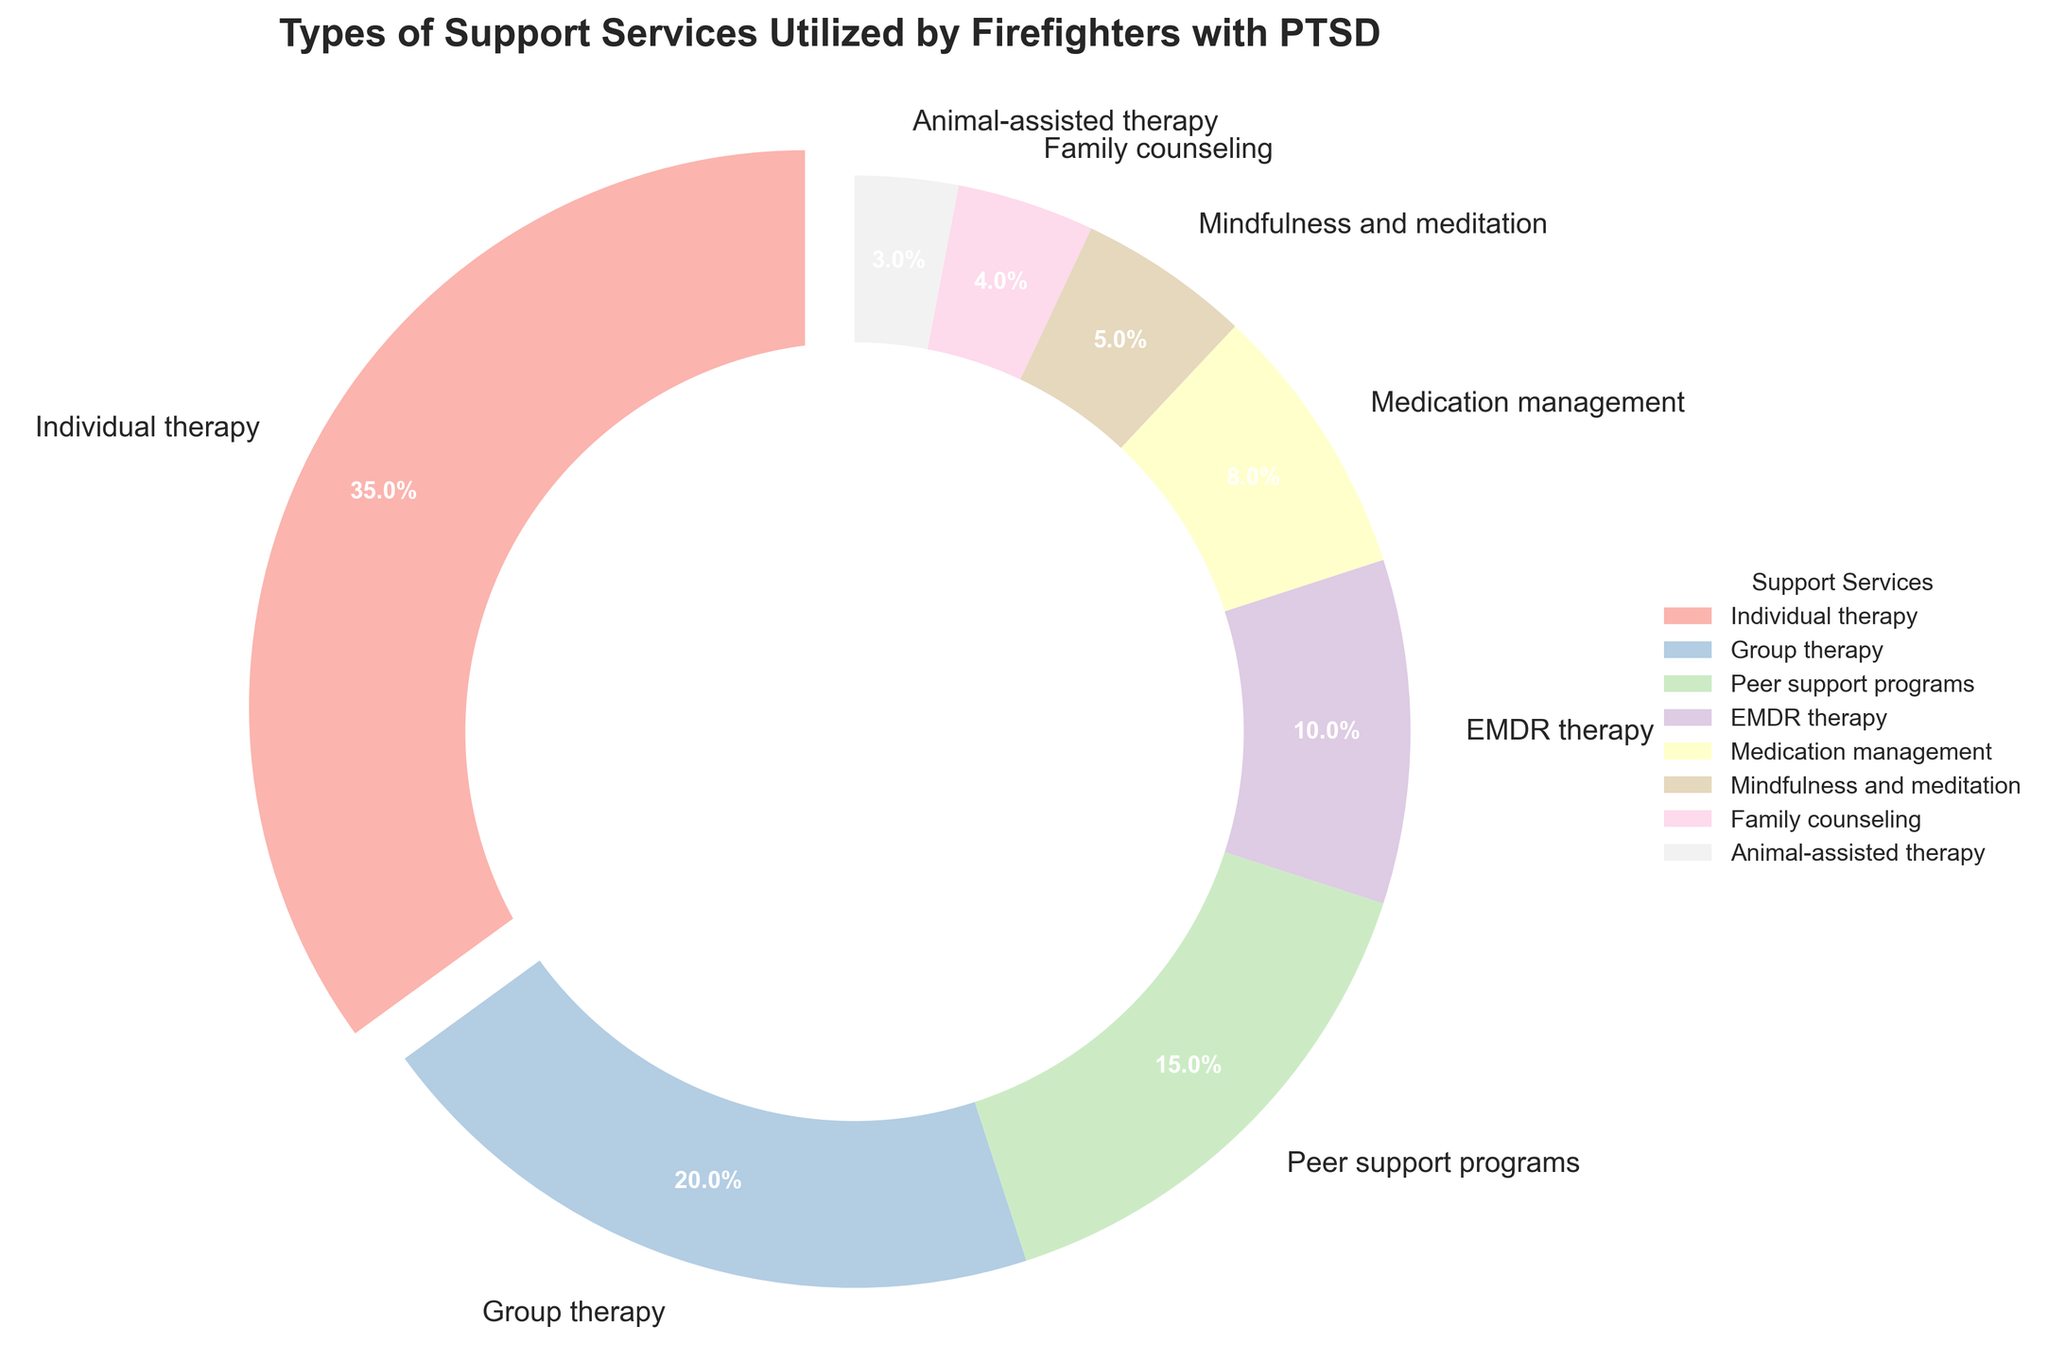What is the most utilized type of support service? The pie chart shows the different types of support services and their percentages. The largest section is labeled "Individual therapy" with 35%.
Answer: Individual therapy What percentage of support services are animal-assisted therapy, family counseling, and mindfulness and meditation combined? Adding the percentages of animal-assisted therapy (3%), family counseling (4%), and mindfulness and meditation (5%), the total is 3% + 4% + 5% = 12%.
Answer: 12% Which category has a smaller percentage of use: medication management or mindfulness and meditation? The segments labeled "Medication management" and "Mindfulness and meditation" indicate their respective percentages, 8% and 5%. Mindfulness and meditation has a smaller percentage.
Answer: Mindfulness and meditation How much more utilized is group therapy compared to family counseling? The pie chart shows group therapy at 20% and family counseling at 4%. The difference is 20% - 4% = 16%.
Answer: 16% What is the total percentage of individual therapy, group therapy, and peer support programs? Adding the percentages of individual therapy (35%), group therapy (20%), and peer support programs (15%), the sum is 35% + 20% + 15% = 70%.
Answer: 70% What is the least utilized type of support service? The segment with the smallest percentage, labeled "Animal-assisted therapy," has 3%.
Answer: Animal-assisted therapy Is EMDR therapy utilized more than medication management? The pie chart shows that EMDR therapy is used by 10% and medication management by 8%. Therefore, EMDR therapy is utilized more.
Answer: Yes What is the difference in percentage between the most and least utilized support services? The most utilized support service is individual therapy (35%) and the least utilized is animal-assisted therapy (3%). The difference is 35% - 3% = 32%.
Answer: 32% How do the percentages of family counseling and animal-assisted therapy compare to that of medication management? Family counseling has 4%, animal-assisted therapy has 3%, totaling 4% + 3% = 7%. Medication management stands at 8%. Thus, family counseling and animal-assisted therapy combined have a slightly lower percentage compared to medication management.
Answer: Lower 